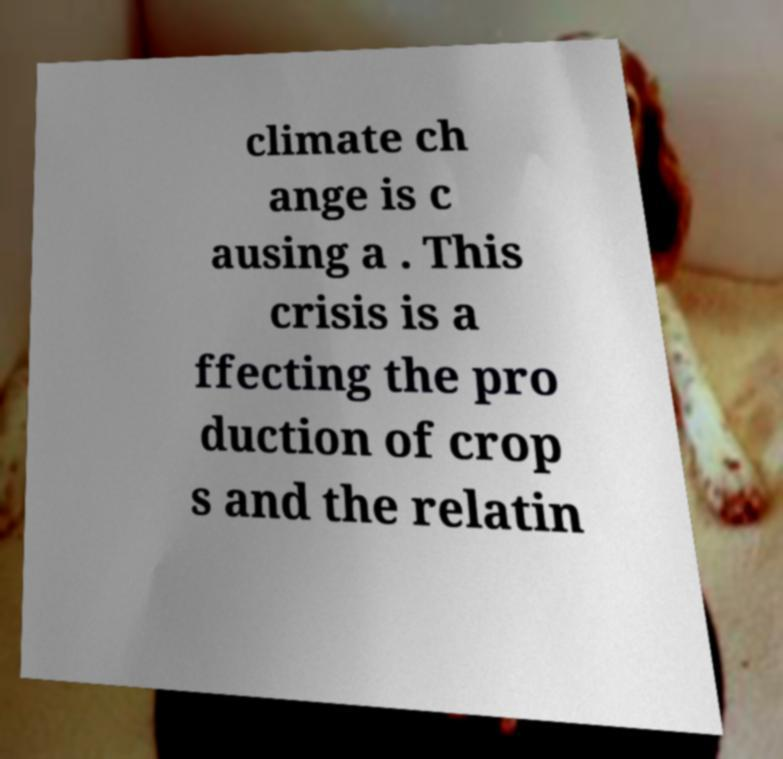Please identify and transcribe the text found in this image. climate ch ange is c ausing a . This crisis is a ffecting the pro duction of crop s and the relatin 